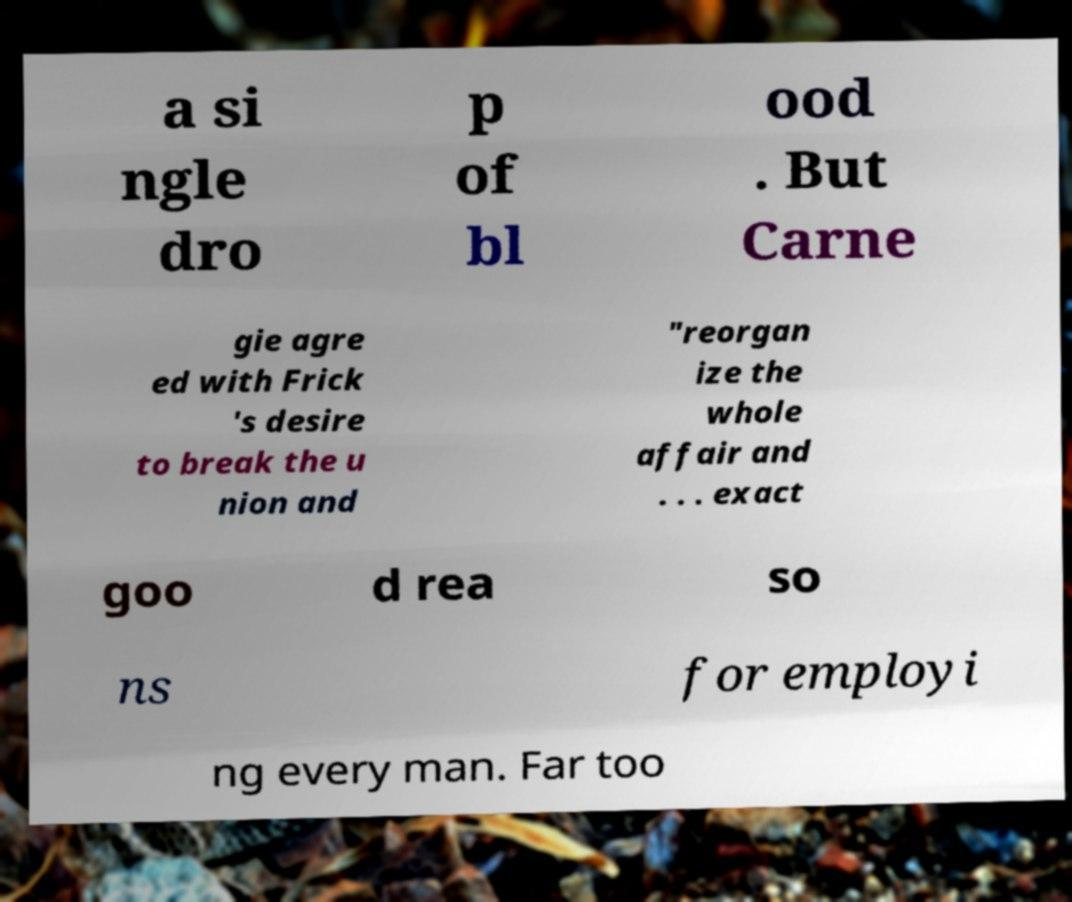Please read and relay the text visible in this image. What does it say? a si ngle dro p of bl ood . But Carne gie agre ed with Frick 's desire to break the u nion and "reorgan ize the whole affair and . . . exact goo d rea so ns for employi ng every man. Far too 